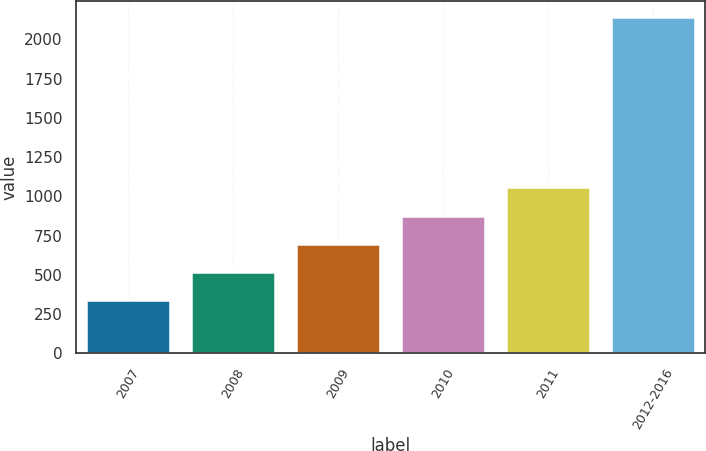Convert chart. <chart><loc_0><loc_0><loc_500><loc_500><bar_chart><fcel>2007<fcel>2008<fcel>2009<fcel>2010<fcel>2011<fcel>2012-2016<nl><fcel>337<fcel>517.4<fcel>697.8<fcel>878.2<fcel>1058.6<fcel>2141<nl></chart> 